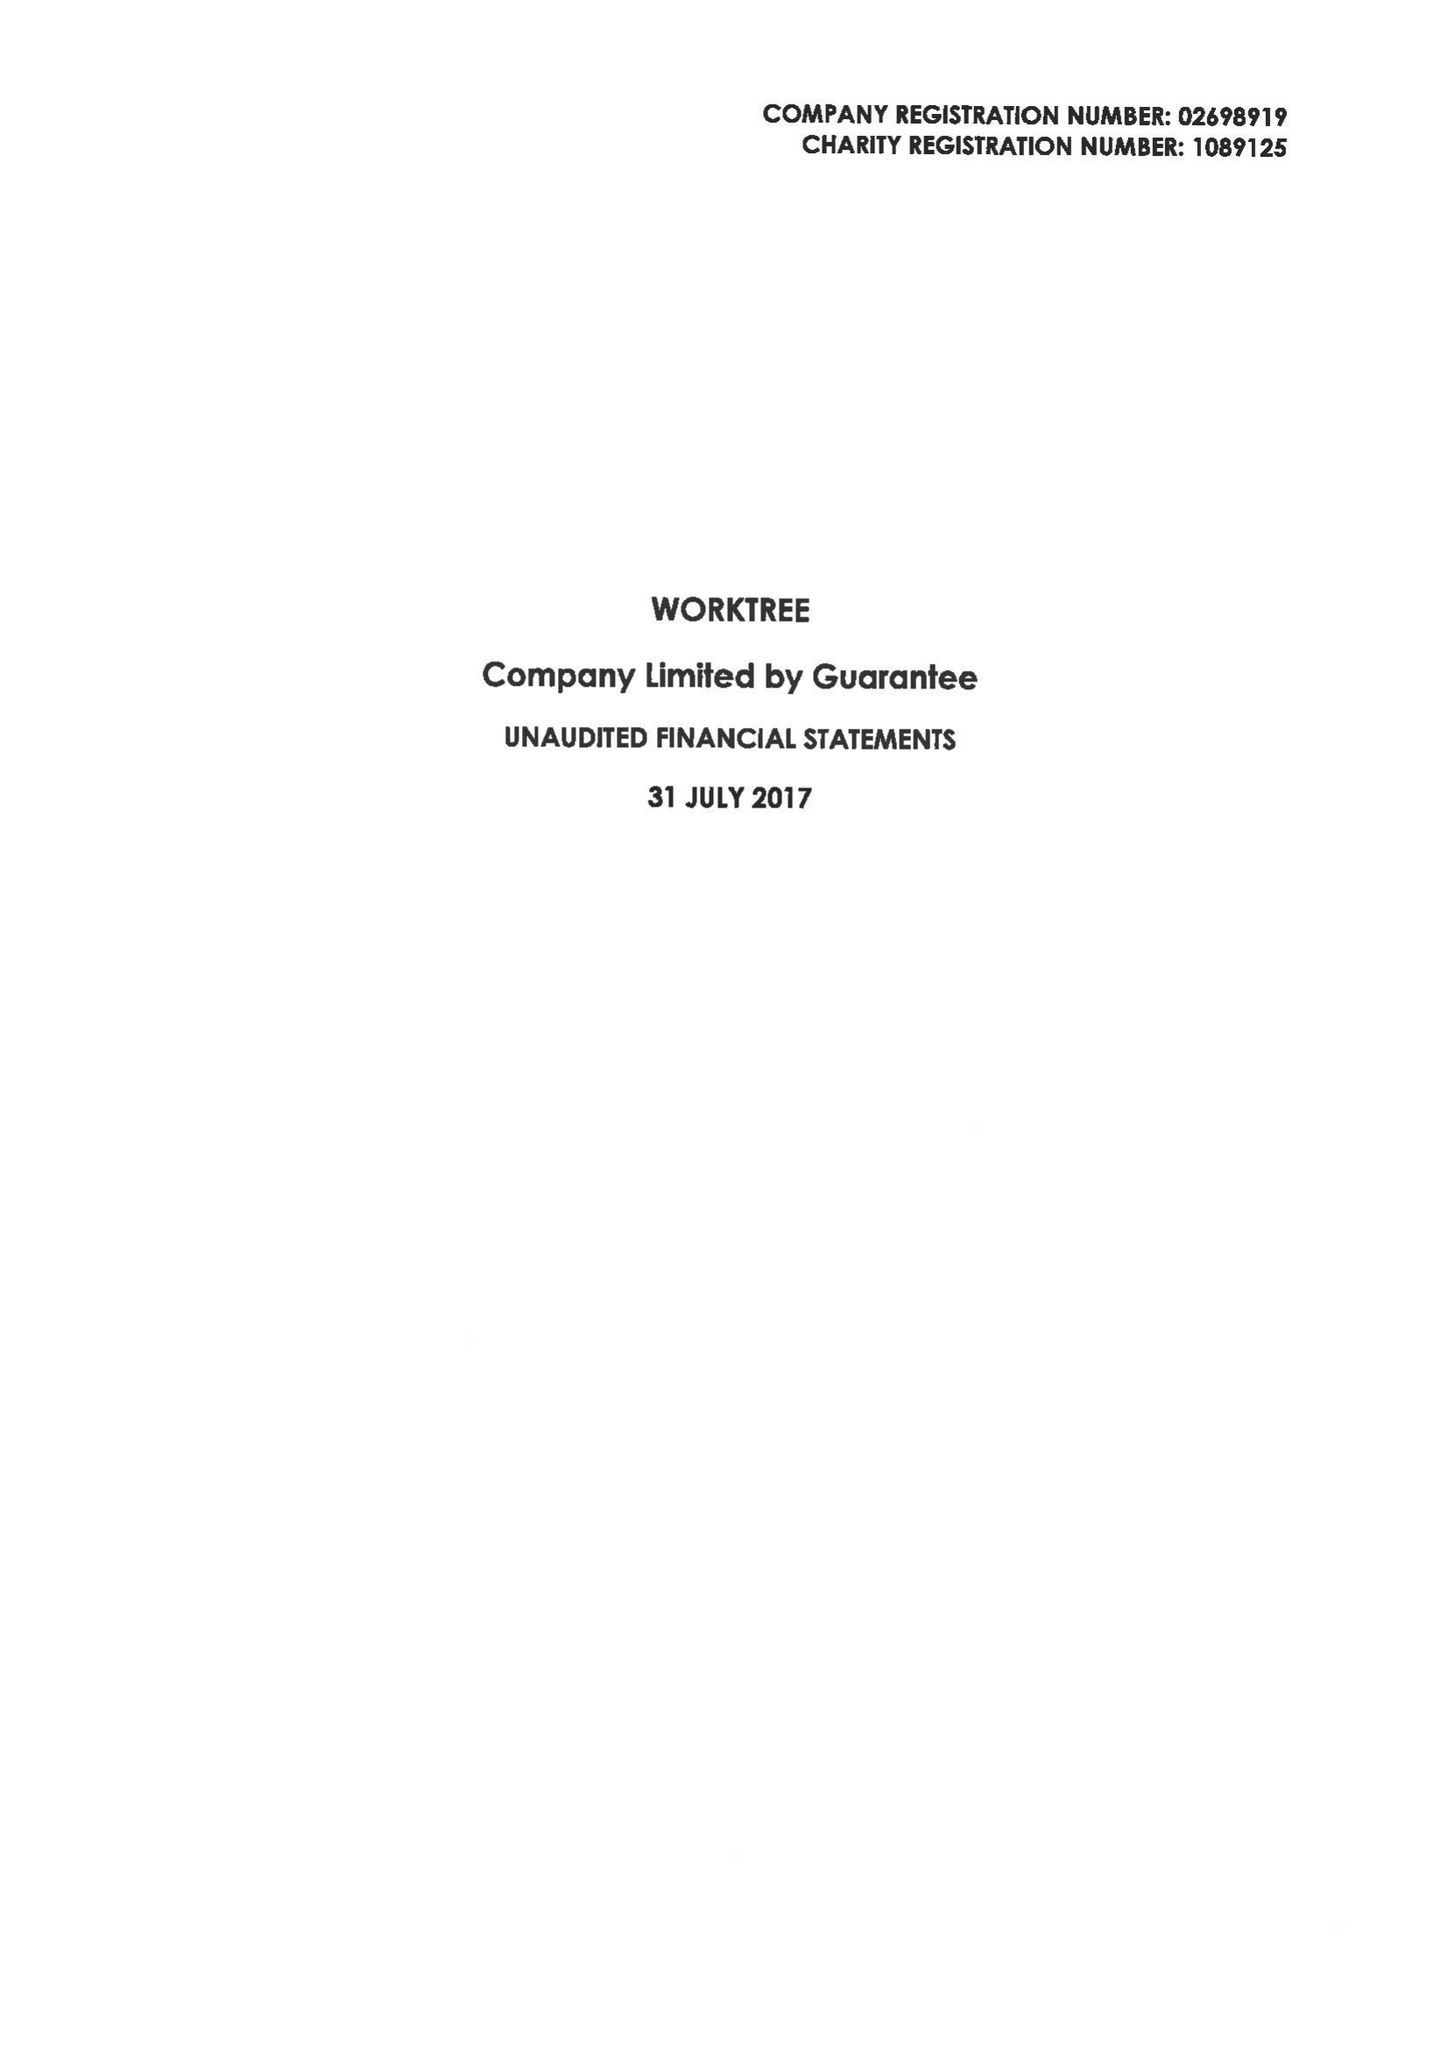What is the value for the address__street_line?
Answer the question using a single word or phrase. 28-29 CLARKE ROAD 